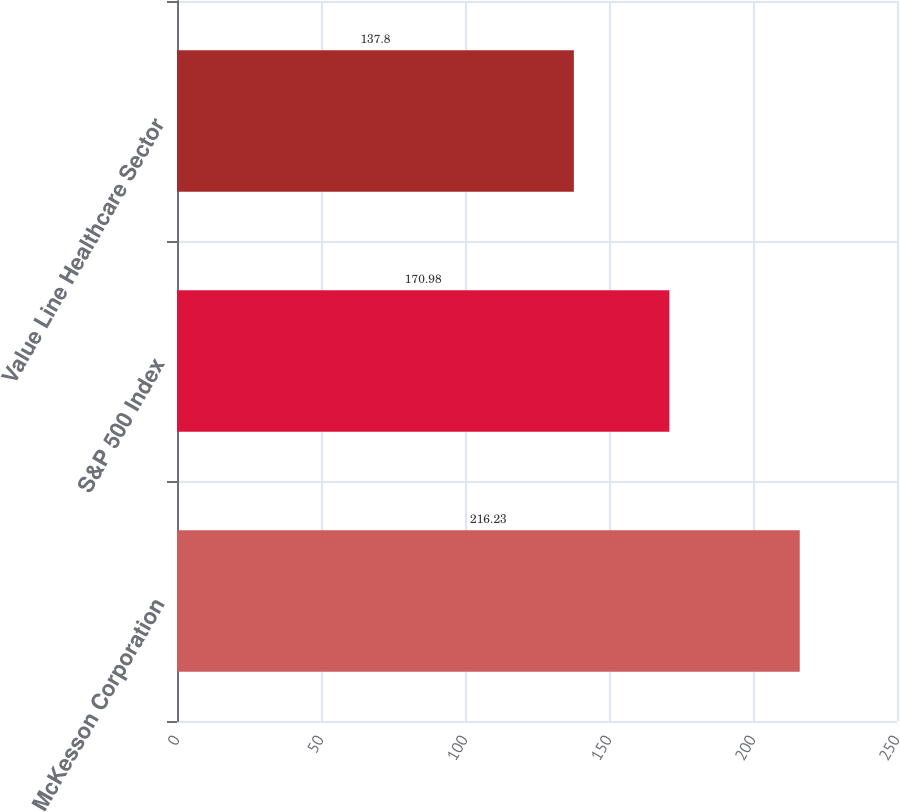Convert chart to OTSL. <chart><loc_0><loc_0><loc_500><loc_500><bar_chart><fcel>McKesson Corporation<fcel>S&P 500 Index<fcel>Value Line Healthcare Sector<nl><fcel>216.23<fcel>170.98<fcel>137.8<nl></chart> 